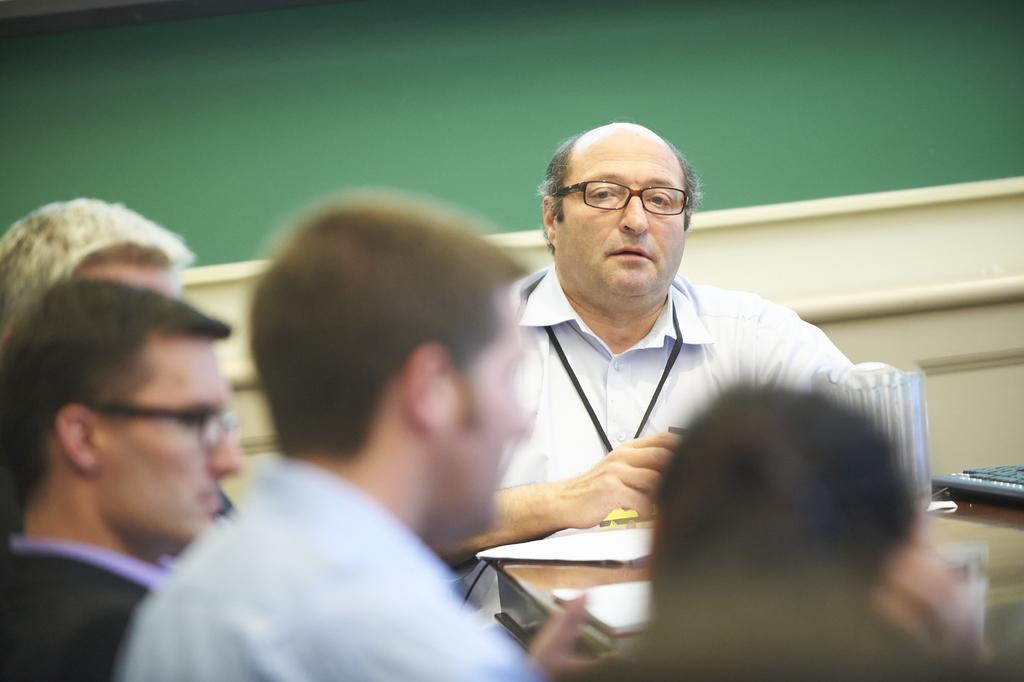Describe this image in one or two sentences. In this image there is a man sitting in the middle. In front of him there is a table on which there are papers,jars, and a keyboard. On the left side there are few other people who are sitting in the chairs. In the background there is a green color board. The man is wearing the spectacles. 